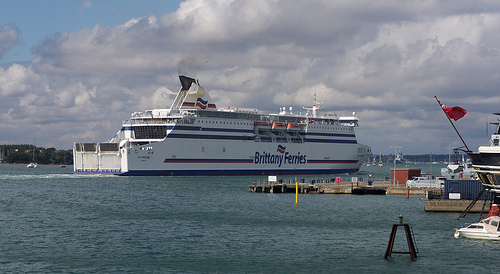Please provide the bounding box coordinate of the region this sentence describes: a section of white clouds. The bounding box coordinates for the section of white clouds are [0.0, 0.35, 0.22, 0.51]. 